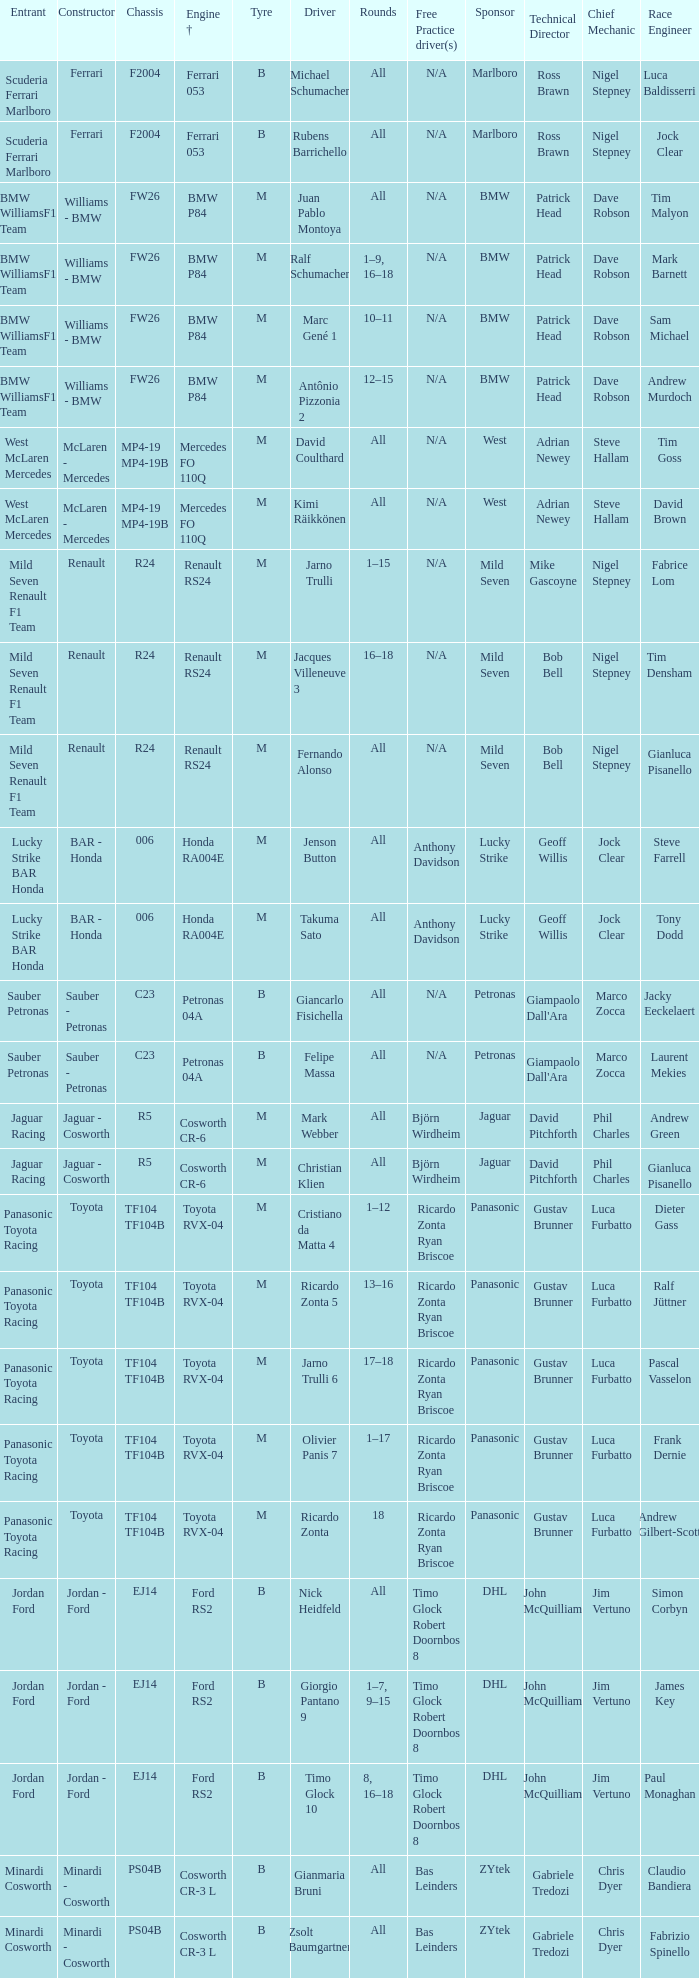What kind of chassis does Ricardo Zonta have? TF104 TF104B. 